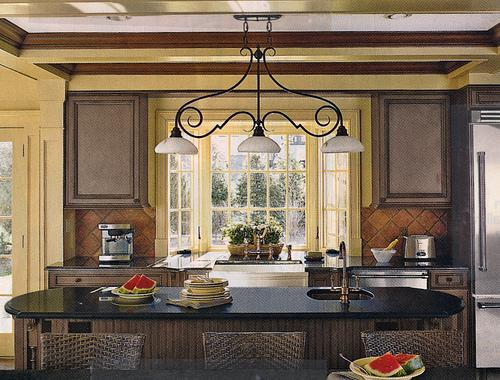Give a brief description of the image focusing on the main objects. The image shows a kitchen with a black countertop, wicker chairs, black table, a white light, a silver refrigerator, and some sliced watermelon on the counter. Can you give a count of the main objects in this image? The image has 1 table, 3 chairs, 2 wooden shelves, 3 light bulbs, a fridge, a faucet, and multiple watermelon slices. What type of chairs are there in the image? There are three woven wicker chairs in the image. List the objects present in the image close to the window. There are plants and a potted plant sitting near the window in the image.  State the location of the watermelon slices in the image. There are sliced watermelon on a plate and in a bowl on the countertop. What appliances are visible in the kitchen? There is a silver refrigerator, a watermelon slice, a silver toaster, and a faucet above the sink in the kitchen. Describe the positioning of the wooden shelves in the image. There is a left brown wooden shelf and a right brown wooden shelf in the image. Tell me about the island in the image. The island features a sink and a faucet above it. Describe the lighting fixture in the image. There is a lighting fixture mounted to the ceiling, with white light bulbs on the left, middle, and right side. What is the position and size of the wooden window frame in the image? The wooden window frame is located at X:203, Y:163 with Width:52 and Height:52. If there is any text present in the image, transcribe it. No text is present in the image. Are the wooden shelves situated on the left side of the image and painted green? The wooden shelves are brown (not green) and located on both the left (X:377 Y:94 Width:71 Height:71) and right sides (X:65 Y:88 Width:88 Height:88) of the image. Is there a whole watermelon lying on the counter in the bottom-left corner? The watermelon is shown as slices, not a whole fruit (X:113 Y:270 Width:45 Height:45, X:365 Y:355 Width:40 Height:40, X:132 Y:273 Width:23 Height:23; among others), and is spread across the counter, not specifically in the bottom-left corner. Among the following options, which objects can you find in the image: 1. plate, 2. toaster, 3. knife, 4. window? 1. plate, 2. toaster, 4. window Describe the color and position of the light source in the image. The light is white and is located at X:165, Y:126. Identify the materials that the chairs are made of. The chairs are made of woven wicker. Can you see a group of people indoors sitting on a sofa? No, it's not mentioned in the image. Rate the quality of this image on a scale of 1 to 10, where 1 is the lowest, and 10 is the highest. 7 Are there any cooking appliances visible in the image? If so, what are they? Yes, there is a silver toaster visible in the image. Count the number of people enjoying the outdoors in the given image. 5 groups of people are enjoying the outdoors. Find the referential expression for the "silver toaster". A silver toaster in a corner at X:401 Y:231 Width:40 Height:40 What would you say is the overall mood or atmosphere of the scene in the image? The atmosphere is cozy and warm. Is there anything unusual or out of place in this image? No, everything in the image seems to be in order. What kind of emotion or sentiment can be derived from the image? The sentiment of the image is relaxed and comfortable. Identify any object interactions in the image. The faucet is above the sink, and sliced watermelon is on a plate. Point out if there are any discrepancies, oddities, or anomalies detected in the image. No, there are no anomalies detected in the image. Is the refrigerator green and located in the bottom right corner of the image? The refrigerator is actually silver and not green, and it is located more towards the top-right corner of the image (X:457 Y:106). Does the image have a red toaster in the center? The toaster in the image is silver (not red) and is situated closer to the top-right corner (X:400 Y:228 Width:41 Height:41). Categorize the various objects in the image based on their semantic attributes. Furniture: chairs, table; Kitchen appliances: sink, faucet, toaster, refrigerator; Decorations: plants, lighting, shelves; Food items: watermelon, plates. What type of lighting fixture is installed in the ceiling? A white light bulb is mounted to the ceiling. Divide the image into segments based on the semantic regions. Segments: light, chairs, table, sink, faucet, plants, watermelon, plates, countertop, refrigerator, window, wooden shelf, toaster, people. Describe the attributes of the three wicker chairs. The three wicker chairs are woven, brown, and located at X:30, Y:329 Determine the location of the silver refrigerator in the image. The silver refrigerator is located at X:457, Y:106. 